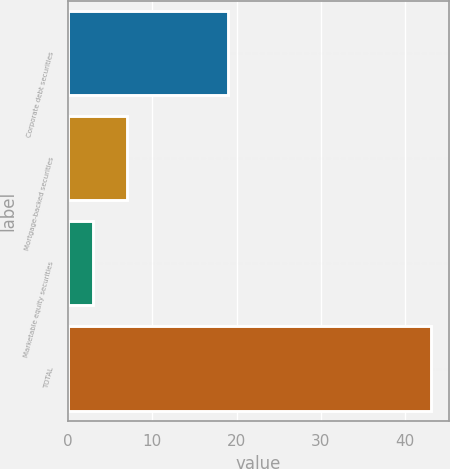Convert chart. <chart><loc_0><loc_0><loc_500><loc_500><bar_chart><fcel>Corporate debt securities<fcel>Mortgage-backed securities<fcel>Marketable equity securities<fcel>TOTAL<nl><fcel>19<fcel>7<fcel>3<fcel>43<nl></chart> 